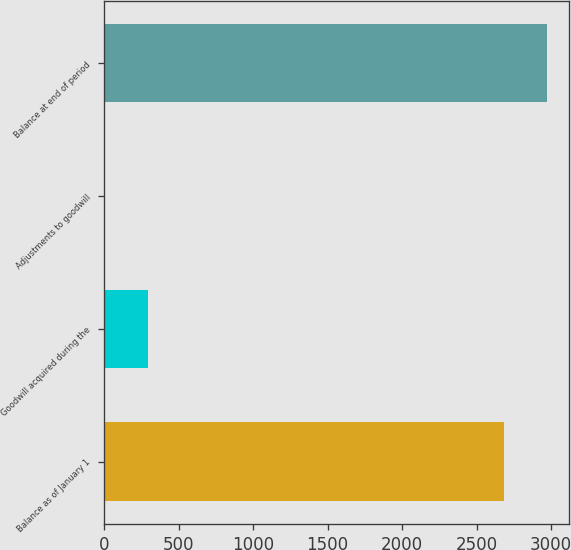<chart> <loc_0><loc_0><loc_500><loc_500><bar_chart><fcel>Balance as of January 1<fcel>Goodwill acquired during the<fcel>Adjustments to goodwill<fcel>Balance at end of period<nl><fcel>2681.8<fcel>294.31<fcel>4.6<fcel>2971.51<nl></chart> 